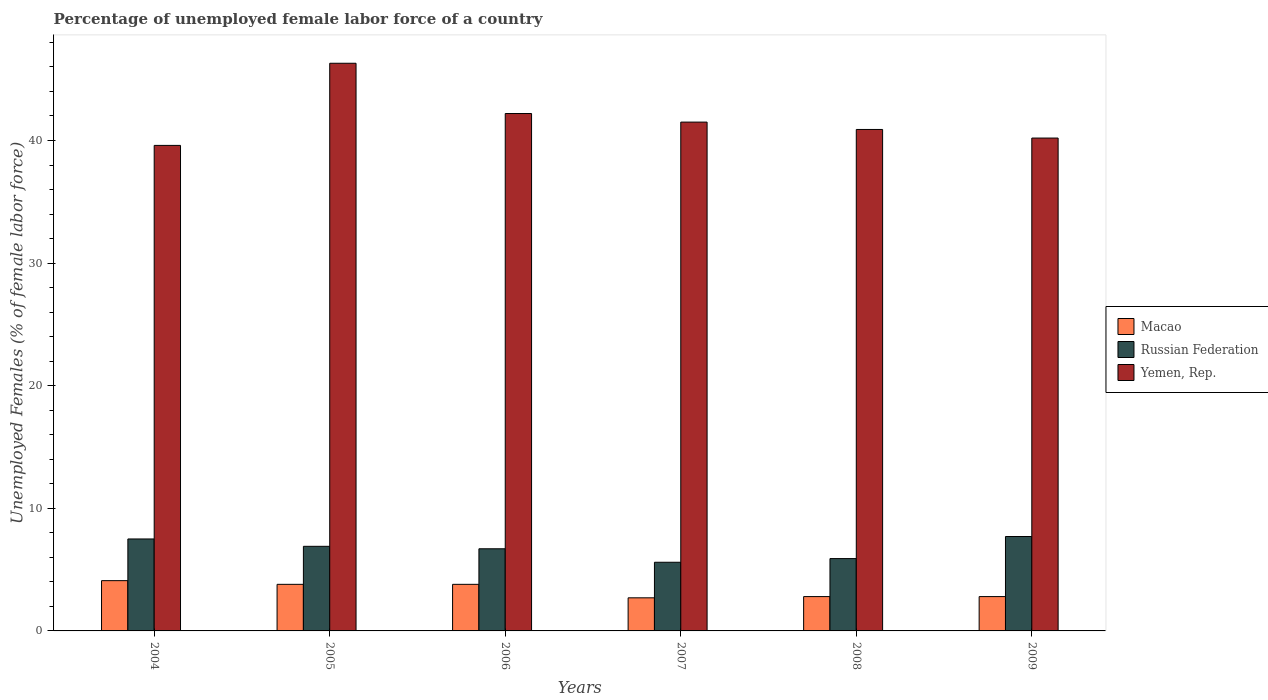How many different coloured bars are there?
Your answer should be compact. 3. How many groups of bars are there?
Provide a succinct answer. 6. Are the number of bars per tick equal to the number of legend labels?
Your answer should be compact. Yes. Are the number of bars on each tick of the X-axis equal?
Give a very brief answer. Yes. How many bars are there on the 4th tick from the left?
Your response must be concise. 3. How many bars are there on the 2nd tick from the right?
Provide a succinct answer. 3. What is the label of the 6th group of bars from the left?
Keep it short and to the point. 2009. In how many cases, is the number of bars for a given year not equal to the number of legend labels?
Your answer should be very brief. 0. What is the percentage of unemployed female labor force in Macao in 2005?
Your answer should be very brief. 3.8. Across all years, what is the maximum percentage of unemployed female labor force in Macao?
Your answer should be very brief. 4.1. Across all years, what is the minimum percentage of unemployed female labor force in Macao?
Your answer should be compact. 2.7. In which year was the percentage of unemployed female labor force in Macao minimum?
Provide a succinct answer. 2007. What is the total percentage of unemployed female labor force in Macao in the graph?
Give a very brief answer. 20. What is the difference between the percentage of unemployed female labor force in Russian Federation in 2005 and that in 2006?
Offer a very short reply. 0.2. What is the difference between the percentage of unemployed female labor force in Russian Federation in 2007 and the percentage of unemployed female labor force in Macao in 2008?
Your answer should be very brief. 2.8. What is the average percentage of unemployed female labor force in Yemen, Rep. per year?
Keep it short and to the point. 41.78. In the year 2008, what is the difference between the percentage of unemployed female labor force in Macao and percentage of unemployed female labor force in Russian Federation?
Provide a short and direct response. -3.1. In how many years, is the percentage of unemployed female labor force in Russian Federation greater than 12 %?
Give a very brief answer. 0. What is the ratio of the percentage of unemployed female labor force in Russian Federation in 2005 to that in 2006?
Make the answer very short. 1.03. Is the percentage of unemployed female labor force in Macao in 2005 less than that in 2009?
Offer a terse response. No. What is the difference between the highest and the second highest percentage of unemployed female labor force in Russian Federation?
Provide a short and direct response. 0.2. What is the difference between the highest and the lowest percentage of unemployed female labor force in Macao?
Keep it short and to the point. 1.4. What does the 2nd bar from the left in 2007 represents?
Give a very brief answer. Russian Federation. What does the 2nd bar from the right in 2008 represents?
Your answer should be very brief. Russian Federation. Is it the case that in every year, the sum of the percentage of unemployed female labor force in Russian Federation and percentage of unemployed female labor force in Yemen, Rep. is greater than the percentage of unemployed female labor force in Macao?
Provide a succinct answer. Yes. How many bars are there?
Provide a short and direct response. 18. Are all the bars in the graph horizontal?
Provide a succinct answer. No. Are the values on the major ticks of Y-axis written in scientific E-notation?
Give a very brief answer. No. Does the graph contain grids?
Ensure brevity in your answer.  No. How many legend labels are there?
Your answer should be compact. 3. How are the legend labels stacked?
Give a very brief answer. Vertical. What is the title of the graph?
Your answer should be compact. Percentage of unemployed female labor force of a country. Does "United Kingdom" appear as one of the legend labels in the graph?
Offer a very short reply. No. What is the label or title of the X-axis?
Your answer should be very brief. Years. What is the label or title of the Y-axis?
Give a very brief answer. Unemployed Females (% of female labor force). What is the Unemployed Females (% of female labor force) of Macao in 2004?
Your answer should be compact. 4.1. What is the Unemployed Females (% of female labor force) in Yemen, Rep. in 2004?
Provide a succinct answer. 39.6. What is the Unemployed Females (% of female labor force) of Macao in 2005?
Your response must be concise. 3.8. What is the Unemployed Females (% of female labor force) of Russian Federation in 2005?
Offer a very short reply. 6.9. What is the Unemployed Females (% of female labor force) of Yemen, Rep. in 2005?
Make the answer very short. 46.3. What is the Unemployed Females (% of female labor force) in Macao in 2006?
Ensure brevity in your answer.  3.8. What is the Unemployed Females (% of female labor force) in Russian Federation in 2006?
Offer a terse response. 6.7. What is the Unemployed Females (% of female labor force) of Yemen, Rep. in 2006?
Provide a short and direct response. 42.2. What is the Unemployed Females (% of female labor force) in Macao in 2007?
Keep it short and to the point. 2.7. What is the Unemployed Females (% of female labor force) in Russian Federation in 2007?
Ensure brevity in your answer.  5.6. What is the Unemployed Females (% of female labor force) in Yemen, Rep. in 2007?
Provide a succinct answer. 41.5. What is the Unemployed Females (% of female labor force) of Macao in 2008?
Offer a terse response. 2.8. What is the Unemployed Females (% of female labor force) in Russian Federation in 2008?
Provide a short and direct response. 5.9. What is the Unemployed Females (% of female labor force) in Yemen, Rep. in 2008?
Ensure brevity in your answer.  40.9. What is the Unemployed Females (% of female labor force) in Macao in 2009?
Your answer should be compact. 2.8. What is the Unemployed Females (% of female labor force) of Russian Federation in 2009?
Make the answer very short. 7.7. What is the Unemployed Females (% of female labor force) of Yemen, Rep. in 2009?
Provide a short and direct response. 40.2. Across all years, what is the maximum Unemployed Females (% of female labor force) in Macao?
Offer a terse response. 4.1. Across all years, what is the maximum Unemployed Females (% of female labor force) in Russian Federation?
Keep it short and to the point. 7.7. Across all years, what is the maximum Unemployed Females (% of female labor force) of Yemen, Rep.?
Give a very brief answer. 46.3. Across all years, what is the minimum Unemployed Females (% of female labor force) of Macao?
Keep it short and to the point. 2.7. Across all years, what is the minimum Unemployed Females (% of female labor force) in Russian Federation?
Make the answer very short. 5.6. Across all years, what is the minimum Unemployed Females (% of female labor force) of Yemen, Rep.?
Make the answer very short. 39.6. What is the total Unemployed Females (% of female labor force) of Russian Federation in the graph?
Your response must be concise. 40.3. What is the total Unemployed Females (% of female labor force) of Yemen, Rep. in the graph?
Offer a terse response. 250.7. What is the difference between the Unemployed Females (% of female labor force) in Macao in 2004 and that in 2005?
Ensure brevity in your answer.  0.3. What is the difference between the Unemployed Females (% of female labor force) in Russian Federation in 2004 and that in 2005?
Keep it short and to the point. 0.6. What is the difference between the Unemployed Females (% of female labor force) in Yemen, Rep. in 2004 and that in 2005?
Ensure brevity in your answer.  -6.7. What is the difference between the Unemployed Females (% of female labor force) in Macao in 2004 and that in 2006?
Your answer should be very brief. 0.3. What is the difference between the Unemployed Females (% of female labor force) of Russian Federation in 2004 and that in 2006?
Offer a very short reply. 0.8. What is the difference between the Unemployed Females (% of female labor force) in Yemen, Rep. in 2004 and that in 2006?
Ensure brevity in your answer.  -2.6. What is the difference between the Unemployed Females (% of female labor force) of Macao in 2004 and that in 2007?
Give a very brief answer. 1.4. What is the difference between the Unemployed Females (% of female labor force) of Russian Federation in 2004 and that in 2007?
Offer a terse response. 1.9. What is the difference between the Unemployed Females (% of female labor force) of Macao in 2004 and that in 2008?
Ensure brevity in your answer.  1.3. What is the difference between the Unemployed Females (% of female labor force) in Yemen, Rep. in 2004 and that in 2008?
Provide a succinct answer. -1.3. What is the difference between the Unemployed Females (% of female labor force) of Macao in 2005 and that in 2007?
Keep it short and to the point. 1.1. What is the difference between the Unemployed Females (% of female labor force) of Yemen, Rep. in 2005 and that in 2007?
Provide a succinct answer. 4.8. What is the difference between the Unemployed Females (% of female labor force) in Yemen, Rep. in 2005 and that in 2008?
Your answer should be compact. 5.4. What is the difference between the Unemployed Females (% of female labor force) of Macao in 2005 and that in 2009?
Keep it short and to the point. 1. What is the difference between the Unemployed Females (% of female labor force) in Russian Federation in 2005 and that in 2009?
Ensure brevity in your answer.  -0.8. What is the difference between the Unemployed Females (% of female labor force) in Yemen, Rep. in 2005 and that in 2009?
Your answer should be very brief. 6.1. What is the difference between the Unemployed Females (% of female labor force) in Macao in 2006 and that in 2007?
Offer a terse response. 1.1. What is the difference between the Unemployed Females (% of female labor force) in Russian Federation in 2006 and that in 2007?
Your answer should be very brief. 1.1. What is the difference between the Unemployed Females (% of female labor force) of Yemen, Rep. in 2006 and that in 2007?
Your answer should be compact. 0.7. What is the difference between the Unemployed Females (% of female labor force) of Macao in 2006 and that in 2008?
Provide a short and direct response. 1. What is the difference between the Unemployed Females (% of female labor force) in Yemen, Rep. in 2006 and that in 2008?
Your answer should be compact. 1.3. What is the difference between the Unemployed Females (% of female labor force) of Macao in 2006 and that in 2009?
Make the answer very short. 1. What is the difference between the Unemployed Females (% of female labor force) of Yemen, Rep. in 2006 and that in 2009?
Keep it short and to the point. 2. What is the difference between the Unemployed Females (% of female labor force) of Macao in 2007 and that in 2008?
Ensure brevity in your answer.  -0.1. What is the difference between the Unemployed Females (% of female labor force) in Russian Federation in 2007 and that in 2008?
Your answer should be compact. -0.3. What is the difference between the Unemployed Females (% of female labor force) of Macao in 2007 and that in 2009?
Keep it short and to the point. -0.1. What is the difference between the Unemployed Females (% of female labor force) of Russian Federation in 2008 and that in 2009?
Make the answer very short. -1.8. What is the difference between the Unemployed Females (% of female labor force) of Macao in 2004 and the Unemployed Females (% of female labor force) of Yemen, Rep. in 2005?
Give a very brief answer. -42.2. What is the difference between the Unemployed Females (% of female labor force) of Russian Federation in 2004 and the Unemployed Females (% of female labor force) of Yemen, Rep. in 2005?
Give a very brief answer. -38.8. What is the difference between the Unemployed Females (% of female labor force) in Macao in 2004 and the Unemployed Females (% of female labor force) in Russian Federation in 2006?
Provide a short and direct response. -2.6. What is the difference between the Unemployed Females (% of female labor force) of Macao in 2004 and the Unemployed Females (% of female labor force) of Yemen, Rep. in 2006?
Offer a very short reply. -38.1. What is the difference between the Unemployed Females (% of female labor force) of Russian Federation in 2004 and the Unemployed Females (% of female labor force) of Yemen, Rep. in 2006?
Offer a very short reply. -34.7. What is the difference between the Unemployed Females (% of female labor force) of Macao in 2004 and the Unemployed Females (% of female labor force) of Russian Federation in 2007?
Provide a succinct answer. -1.5. What is the difference between the Unemployed Females (% of female labor force) of Macao in 2004 and the Unemployed Females (% of female labor force) of Yemen, Rep. in 2007?
Offer a terse response. -37.4. What is the difference between the Unemployed Females (% of female labor force) in Russian Federation in 2004 and the Unemployed Females (% of female labor force) in Yemen, Rep. in 2007?
Your response must be concise. -34. What is the difference between the Unemployed Females (% of female labor force) in Macao in 2004 and the Unemployed Females (% of female labor force) in Russian Federation in 2008?
Provide a short and direct response. -1.8. What is the difference between the Unemployed Females (% of female labor force) of Macao in 2004 and the Unemployed Females (% of female labor force) of Yemen, Rep. in 2008?
Make the answer very short. -36.8. What is the difference between the Unemployed Females (% of female labor force) of Russian Federation in 2004 and the Unemployed Females (% of female labor force) of Yemen, Rep. in 2008?
Your answer should be compact. -33.4. What is the difference between the Unemployed Females (% of female labor force) in Macao in 2004 and the Unemployed Females (% of female labor force) in Yemen, Rep. in 2009?
Make the answer very short. -36.1. What is the difference between the Unemployed Females (% of female labor force) in Russian Federation in 2004 and the Unemployed Females (% of female labor force) in Yemen, Rep. in 2009?
Your answer should be compact. -32.7. What is the difference between the Unemployed Females (% of female labor force) in Macao in 2005 and the Unemployed Females (% of female labor force) in Russian Federation in 2006?
Provide a short and direct response. -2.9. What is the difference between the Unemployed Females (% of female labor force) in Macao in 2005 and the Unemployed Females (% of female labor force) in Yemen, Rep. in 2006?
Make the answer very short. -38.4. What is the difference between the Unemployed Females (% of female labor force) of Russian Federation in 2005 and the Unemployed Females (% of female labor force) of Yemen, Rep. in 2006?
Provide a succinct answer. -35.3. What is the difference between the Unemployed Females (% of female labor force) in Macao in 2005 and the Unemployed Females (% of female labor force) in Yemen, Rep. in 2007?
Keep it short and to the point. -37.7. What is the difference between the Unemployed Females (% of female labor force) of Russian Federation in 2005 and the Unemployed Females (% of female labor force) of Yemen, Rep. in 2007?
Your answer should be very brief. -34.6. What is the difference between the Unemployed Females (% of female labor force) of Macao in 2005 and the Unemployed Females (% of female labor force) of Russian Federation in 2008?
Your answer should be very brief. -2.1. What is the difference between the Unemployed Females (% of female labor force) of Macao in 2005 and the Unemployed Females (% of female labor force) of Yemen, Rep. in 2008?
Offer a very short reply. -37.1. What is the difference between the Unemployed Females (% of female labor force) of Russian Federation in 2005 and the Unemployed Females (% of female labor force) of Yemen, Rep. in 2008?
Make the answer very short. -34. What is the difference between the Unemployed Females (% of female labor force) in Macao in 2005 and the Unemployed Females (% of female labor force) in Russian Federation in 2009?
Give a very brief answer. -3.9. What is the difference between the Unemployed Females (% of female labor force) in Macao in 2005 and the Unemployed Females (% of female labor force) in Yemen, Rep. in 2009?
Your response must be concise. -36.4. What is the difference between the Unemployed Females (% of female labor force) in Russian Federation in 2005 and the Unemployed Females (% of female labor force) in Yemen, Rep. in 2009?
Provide a short and direct response. -33.3. What is the difference between the Unemployed Females (% of female labor force) of Macao in 2006 and the Unemployed Females (% of female labor force) of Yemen, Rep. in 2007?
Make the answer very short. -37.7. What is the difference between the Unemployed Females (% of female labor force) of Russian Federation in 2006 and the Unemployed Females (% of female labor force) of Yemen, Rep. in 2007?
Give a very brief answer. -34.8. What is the difference between the Unemployed Females (% of female labor force) in Macao in 2006 and the Unemployed Females (% of female labor force) in Russian Federation in 2008?
Provide a succinct answer. -2.1. What is the difference between the Unemployed Females (% of female labor force) in Macao in 2006 and the Unemployed Females (% of female labor force) in Yemen, Rep. in 2008?
Provide a succinct answer. -37.1. What is the difference between the Unemployed Females (% of female labor force) in Russian Federation in 2006 and the Unemployed Females (% of female labor force) in Yemen, Rep. in 2008?
Give a very brief answer. -34.2. What is the difference between the Unemployed Females (% of female labor force) in Macao in 2006 and the Unemployed Females (% of female labor force) in Yemen, Rep. in 2009?
Your answer should be compact. -36.4. What is the difference between the Unemployed Females (% of female labor force) of Russian Federation in 2006 and the Unemployed Females (% of female labor force) of Yemen, Rep. in 2009?
Make the answer very short. -33.5. What is the difference between the Unemployed Females (% of female labor force) of Macao in 2007 and the Unemployed Females (% of female labor force) of Yemen, Rep. in 2008?
Your answer should be compact. -38.2. What is the difference between the Unemployed Females (% of female labor force) in Russian Federation in 2007 and the Unemployed Females (% of female labor force) in Yemen, Rep. in 2008?
Make the answer very short. -35.3. What is the difference between the Unemployed Females (% of female labor force) in Macao in 2007 and the Unemployed Females (% of female labor force) in Yemen, Rep. in 2009?
Provide a short and direct response. -37.5. What is the difference between the Unemployed Females (% of female labor force) of Russian Federation in 2007 and the Unemployed Females (% of female labor force) of Yemen, Rep. in 2009?
Offer a terse response. -34.6. What is the difference between the Unemployed Females (% of female labor force) in Macao in 2008 and the Unemployed Females (% of female labor force) in Yemen, Rep. in 2009?
Offer a terse response. -37.4. What is the difference between the Unemployed Females (% of female labor force) of Russian Federation in 2008 and the Unemployed Females (% of female labor force) of Yemen, Rep. in 2009?
Make the answer very short. -34.3. What is the average Unemployed Females (% of female labor force) of Russian Federation per year?
Offer a terse response. 6.72. What is the average Unemployed Females (% of female labor force) of Yemen, Rep. per year?
Make the answer very short. 41.78. In the year 2004, what is the difference between the Unemployed Females (% of female labor force) of Macao and Unemployed Females (% of female labor force) of Yemen, Rep.?
Offer a very short reply. -35.5. In the year 2004, what is the difference between the Unemployed Females (% of female labor force) of Russian Federation and Unemployed Females (% of female labor force) of Yemen, Rep.?
Your response must be concise. -32.1. In the year 2005, what is the difference between the Unemployed Females (% of female labor force) in Macao and Unemployed Females (% of female labor force) in Yemen, Rep.?
Keep it short and to the point. -42.5. In the year 2005, what is the difference between the Unemployed Females (% of female labor force) in Russian Federation and Unemployed Females (% of female labor force) in Yemen, Rep.?
Offer a terse response. -39.4. In the year 2006, what is the difference between the Unemployed Females (% of female labor force) in Macao and Unemployed Females (% of female labor force) in Russian Federation?
Ensure brevity in your answer.  -2.9. In the year 2006, what is the difference between the Unemployed Females (% of female labor force) of Macao and Unemployed Females (% of female labor force) of Yemen, Rep.?
Your answer should be very brief. -38.4. In the year 2006, what is the difference between the Unemployed Females (% of female labor force) of Russian Federation and Unemployed Females (% of female labor force) of Yemen, Rep.?
Provide a short and direct response. -35.5. In the year 2007, what is the difference between the Unemployed Females (% of female labor force) in Macao and Unemployed Females (% of female labor force) in Yemen, Rep.?
Offer a very short reply. -38.8. In the year 2007, what is the difference between the Unemployed Females (% of female labor force) in Russian Federation and Unemployed Females (% of female labor force) in Yemen, Rep.?
Keep it short and to the point. -35.9. In the year 2008, what is the difference between the Unemployed Females (% of female labor force) of Macao and Unemployed Females (% of female labor force) of Yemen, Rep.?
Your response must be concise. -38.1. In the year 2008, what is the difference between the Unemployed Females (% of female labor force) in Russian Federation and Unemployed Females (% of female labor force) in Yemen, Rep.?
Make the answer very short. -35. In the year 2009, what is the difference between the Unemployed Females (% of female labor force) in Macao and Unemployed Females (% of female labor force) in Yemen, Rep.?
Offer a terse response. -37.4. In the year 2009, what is the difference between the Unemployed Females (% of female labor force) in Russian Federation and Unemployed Females (% of female labor force) in Yemen, Rep.?
Your answer should be compact. -32.5. What is the ratio of the Unemployed Females (% of female labor force) of Macao in 2004 to that in 2005?
Your response must be concise. 1.08. What is the ratio of the Unemployed Females (% of female labor force) in Russian Federation in 2004 to that in 2005?
Offer a very short reply. 1.09. What is the ratio of the Unemployed Females (% of female labor force) of Yemen, Rep. in 2004 to that in 2005?
Make the answer very short. 0.86. What is the ratio of the Unemployed Females (% of female labor force) in Macao in 2004 to that in 2006?
Make the answer very short. 1.08. What is the ratio of the Unemployed Females (% of female labor force) in Russian Federation in 2004 to that in 2006?
Offer a very short reply. 1.12. What is the ratio of the Unemployed Females (% of female labor force) of Yemen, Rep. in 2004 to that in 2006?
Give a very brief answer. 0.94. What is the ratio of the Unemployed Females (% of female labor force) in Macao in 2004 to that in 2007?
Give a very brief answer. 1.52. What is the ratio of the Unemployed Females (% of female labor force) in Russian Federation in 2004 to that in 2007?
Your answer should be compact. 1.34. What is the ratio of the Unemployed Females (% of female labor force) of Yemen, Rep. in 2004 to that in 2007?
Your answer should be compact. 0.95. What is the ratio of the Unemployed Females (% of female labor force) of Macao in 2004 to that in 2008?
Ensure brevity in your answer.  1.46. What is the ratio of the Unemployed Females (% of female labor force) in Russian Federation in 2004 to that in 2008?
Offer a terse response. 1.27. What is the ratio of the Unemployed Females (% of female labor force) of Yemen, Rep. in 2004 to that in 2008?
Give a very brief answer. 0.97. What is the ratio of the Unemployed Females (% of female labor force) of Macao in 2004 to that in 2009?
Your answer should be very brief. 1.46. What is the ratio of the Unemployed Females (% of female labor force) of Yemen, Rep. in 2004 to that in 2009?
Provide a short and direct response. 0.99. What is the ratio of the Unemployed Females (% of female labor force) in Russian Federation in 2005 to that in 2006?
Your answer should be compact. 1.03. What is the ratio of the Unemployed Females (% of female labor force) of Yemen, Rep. in 2005 to that in 2006?
Offer a very short reply. 1.1. What is the ratio of the Unemployed Females (% of female labor force) in Macao in 2005 to that in 2007?
Provide a short and direct response. 1.41. What is the ratio of the Unemployed Females (% of female labor force) of Russian Federation in 2005 to that in 2007?
Provide a succinct answer. 1.23. What is the ratio of the Unemployed Females (% of female labor force) in Yemen, Rep. in 2005 to that in 2007?
Provide a succinct answer. 1.12. What is the ratio of the Unemployed Females (% of female labor force) in Macao in 2005 to that in 2008?
Give a very brief answer. 1.36. What is the ratio of the Unemployed Females (% of female labor force) in Russian Federation in 2005 to that in 2008?
Offer a very short reply. 1.17. What is the ratio of the Unemployed Females (% of female labor force) in Yemen, Rep. in 2005 to that in 2008?
Give a very brief answer. 1.13. What is the ratio of the Unemployed Females (% of female labor force) of Macao in 2005 to that in 2009?
Ensure brevity in your answer.  1.36. What is the ratio of the Unemployed Females (% of female labor force) in Russian Federation in 2005 to that in 2009?
Provide a short and direct response. 0.9. What is the ratio of the Unemployed Females (% of female labor force) in Yemen, Rep. in 2005 to that in 2009?
Your answer should be compact. 1.15. What is the ratio of the Unemployed Females (% of female labor force) in Macao in 2006 to that in 2007?
Your answer should be compact. 1.41. What is the ratio of the Unemployed Females (% of female labor force) of Russian Federation in 2006 to that in 2007?
Give a very brief answer. 1.2. What is the ratio of the Unemployed Females (% of female labor force) in Yemen, Rep. in 2006 to that in 2007?
Offer a very short reply. 1.02. What is the ratio of the Unemployed Females (% of female labor force) in Macao in 2006 to that in 2008?
Keep it short and to the point. 1.36. What is the ratio of the Unemployed Females (% of female labor force) in Russian Federation in 2006 to that in 2008?
Make the answer very short. 1.14. What is the ratio of the Unemployed Females (% of female labor force) in Yemen, Rep. in 2006 to that in 2008?
Ensure brevity in your answer.  1.03. What is the ratio of the Unemployed Females (% of female labor force) in Macao in 2006 to that in 2009?
Offer a terse response. 1.36. What is the ratio of the Unemployed Females (% of female labor force) in Russian Federation in 2006 to that in 2009?
Make the answer very short. 0.87. What is the ratio of the Unemployed Females (% of female labor force) in Yemen, Rep. in 2006 to that in 2009?
Provide a short and direct response. 1.05. What is the ratio of the Unemployed Females (% of female labor force) in Russian Federation in 2007 to that in 2008?
Offer a very short reply. 0.95. What is the ratio of the Unemployed Females (% of female labor force) of Yemen, Rep. in 2007 to that in 2008?
Provide a succinct answer. 1.01. What is the ratio of the Unemployed Females (% of female labor force) of Russian Federation in 2007 to that in 2009?
Make the answer very short. 0.73. What is the ratio of the Unemployed Females (% of female labor force) of Yemen, Rep. in 2007 to that in 2009?
Provide a succinct answer. 1.03. What is the ratio of the Unemployed Females (% of female labor force) in Russian Federation in 2008 to that in 2009?
Provide a succinct answer. 0.77. What is the ratio of the Unemployed Females (% of female labor force) of Yemen, Rep. in 2008 to that in 2009?
Your answer should be very brief. 1.02. What is the difference between the highest and the lowest Unemployed Females (% of female labor force) in Russian Federation?
Your answer should be compact. 2.1. 